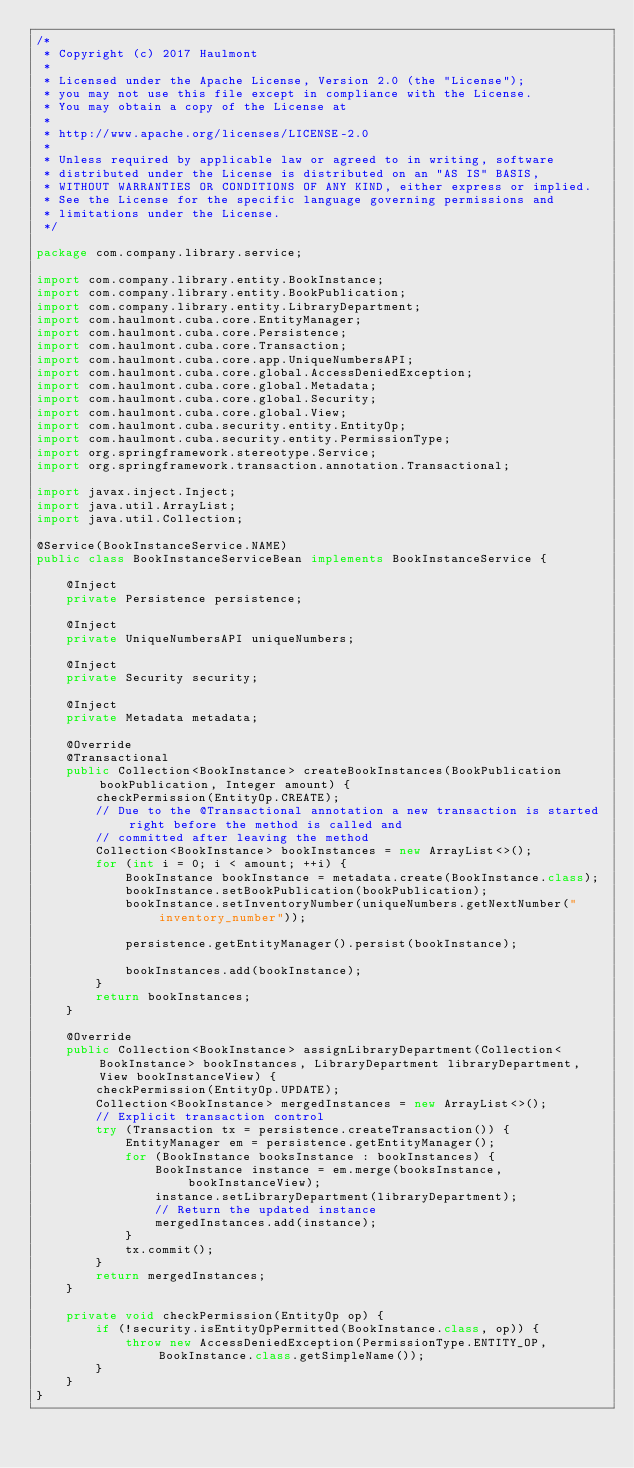Convert code to text. <code><loc_0><loc_0><loc_500><loc_500><_Java_>/*
 * Copyright (c) 2017 Haulmont
 *
 * Licensed under the Apache License, Version 2.0 (the "License");
 * you may not use this file except in compliance with the License.
 * You may obtain a copy of the License at
 *
 * http://www.apache.org/licenses/LICENSE-2.0
 *
 * Unless required by applicable law or agreed to in writing, software
 * distributed under the License is distributed on an "AS IS" BASIS,
 * WITHOUT WARRANTIES OR CONDITIONS OF ANY KIND, either express or implied.
 * See the License for the specific language governing permissions and
 * limitations under the License.
 */

package com.company.library.service;

import com.company.library.entity.BookInstance;
import com.company.library.entity.BookPublication;
import com.company.library.entity.LibraryDepartment;
import com.haulmont.cuba.core.EntityManager;
import com.haulmont.cuba.core.Persistence;
import com.haulmont.cuba.core.Transaction;
import com.haulmont.cuba.core.app.UniqueNumbersAPI;
import com.haulmont.cuba.core.global.AccessDeniedException;
import com.haulmont.cuba.core.global.Metadata;
import com.haulmont.cuba.core.global.Security;
import com.haulmont.cuba.core.global.View;
import com.haulmont.cuba.security.entity.EntityOp;
import com.haulmont.cuba.security.entity.PermissionType;
import org.springframework.stereotype.Service;
import org.springframework.transaction.annotation.Transactional;

import javax.inject.Inject;
import java.util.ArrayList;
import java.util.Collection;

@Service(BookInstanceService.NAME)
public class BookInstanceServiceBean implements BookInstanceService {

    @Inject
    private Persistence persistence;

    @Inject
    private UniqueNumbersAPI uniqueNumbers;

    @Inject
    private Security security;

    @Inject
    private Metadata metadata;

    @Override
    @Transactional
    public Collection<BookInstance> createBookInstances(BookPublication bookPublication, Integer amount) {
        checkPermission(EntityOp.CREATE);
        // Due to the @Transactional annotation a new transaction is started right before the method is called and
        // committed after leaving the method
        Collection<BookInstance> bookInstances = new ArrayList<>();
        for (int i = 0; i < amount; ++i) {
            BookInstance bookInstance = metadata.create(BookInstance.class);
            bookInstance.setBookPublication(bookPublication);
            bookInstance.setInventoryNumber(uniqueNumbers.getNextNumber("inventory_number"));

            persistence.getEntityManager().persist(bookInstance);

            bookInstances.add(bookInstance);
        }
        return bookInstances;
    }

    @Override
    public Collection<BookInstance> assignLibraryDepartment(Collection<BookInstance> bookInstances, LibraryDepartment libraryDepartment, View bookInstanceView) {
        checkPermission(EntityOp.UPDATE);
        Collection<BookInstance> mergedInstances = new ArrayList<>();
        // Explicit transaction control
        try (Transaction tx = persistence.createTransaction()) {
            EntityManager em = persistence.getEntityManager();
            for (BookInstance booksInstance : bookInstances) {
                BookInstance instance = em.merge(booksInstance, bookInstanceView);
                instance.setLibraryDepartment(libraryDepartment);
                // Return the updated instance
                mergedInstances.add(instance);
            }
            tx.commit();
        }
        return mergedInstances;
    }

    private void checkPermission(EntityOp op) {
        if (!security.isEntityOpPermitted(BookInstance.class, op)) {
            throw new AccessDeniedException(PermissionType.ENTITY_OP, BookInstance.class.getSimpleName());
        }
    }
}</code> 